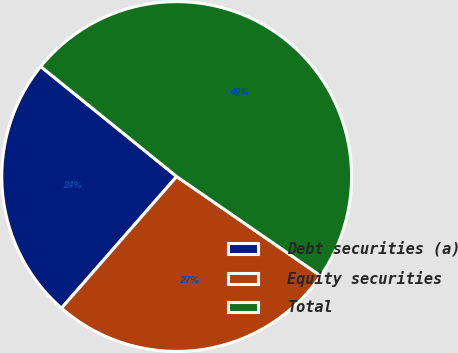Convert chart to OTSL. <chart><loc_0><loc_0><loc_500><loc_500><pie_chart><fcel>Debt securities (a)<fcel>Equity securities<fcel>Total<nl><fcel>24.39%<fcel>26.83%<fcel>48.78%<nl></chart> 